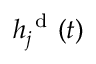Convert formula to latex. <formula><loc_0><loc_0><loc_500><loc_500>h _ { j } ^ { d } ( t )</formula> 